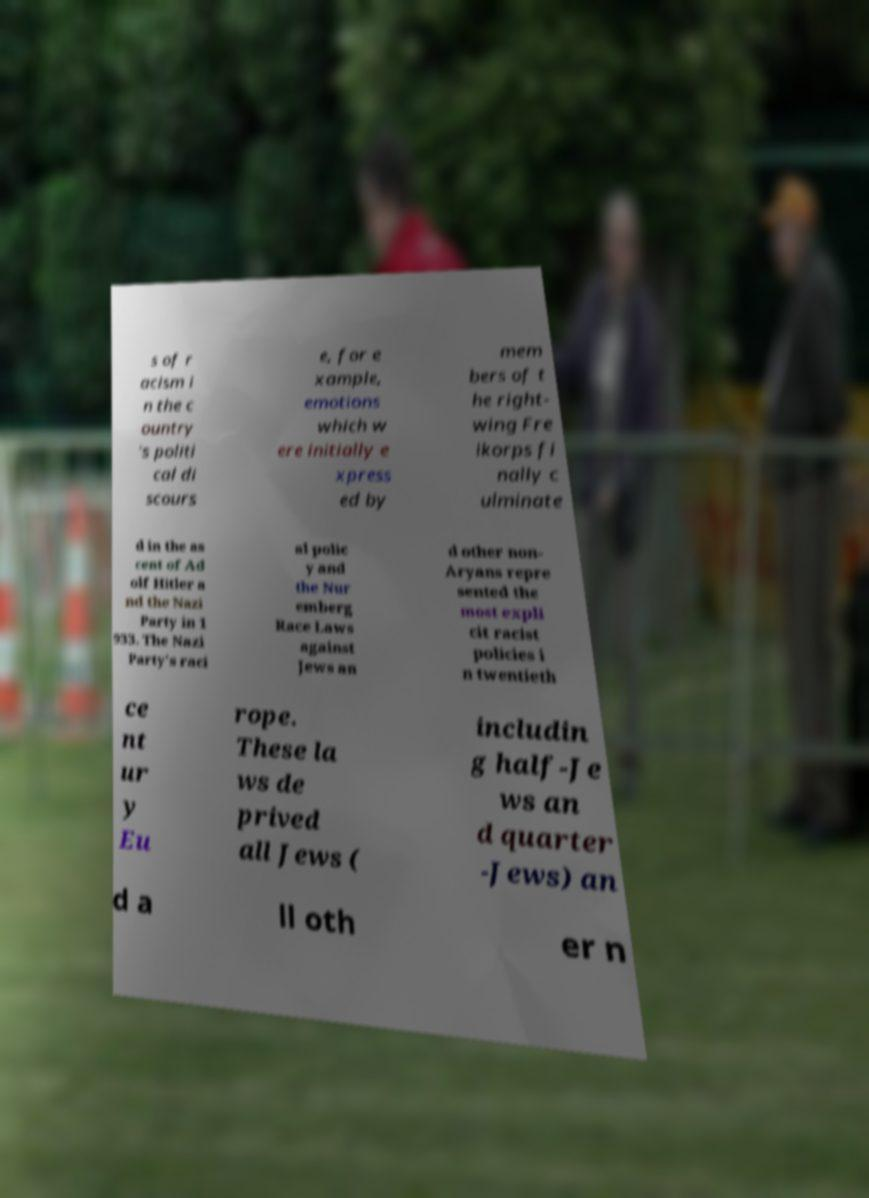Can you accurately transcribe the text from the provided image for me? s of r acism i n the c ountry 's politi cal di scours e, for e xample, emotions which w ere initially e xpress ed by mem bers of t he right- wing Fre ikorps fi nally c ulminate d in the as cent of Ad olf Hitler a nd the Nazi Party in 1 933. The Nazi Party's raci al polic y and the Nur emberg Race Laws against Jews an d other non- Aryans repre sented the most expli cit racist policies i n twentieth ce nt ur y Eu rope. These la ws de prived all Jews ( includin g half-Je ws an d quarter -Jews) an d a ll oth er n 